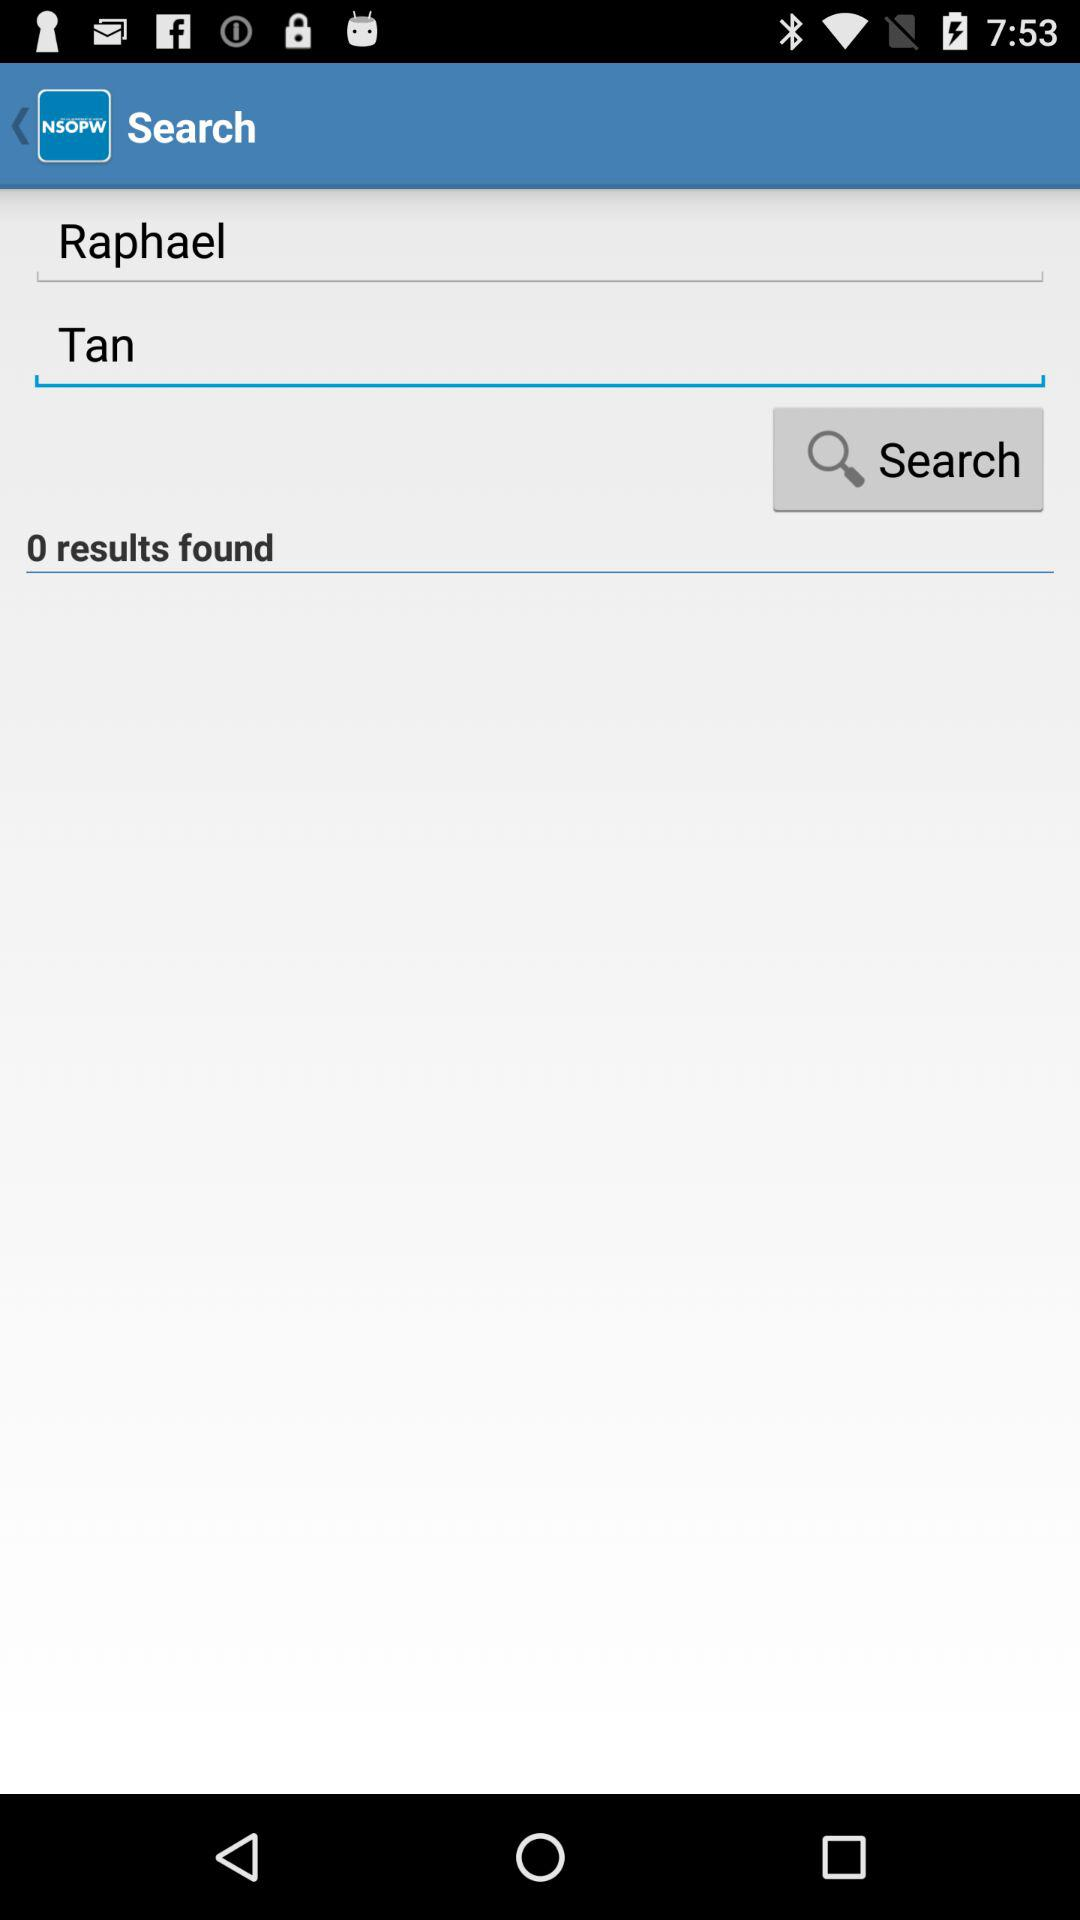How many results were found? There were 0 results found. 